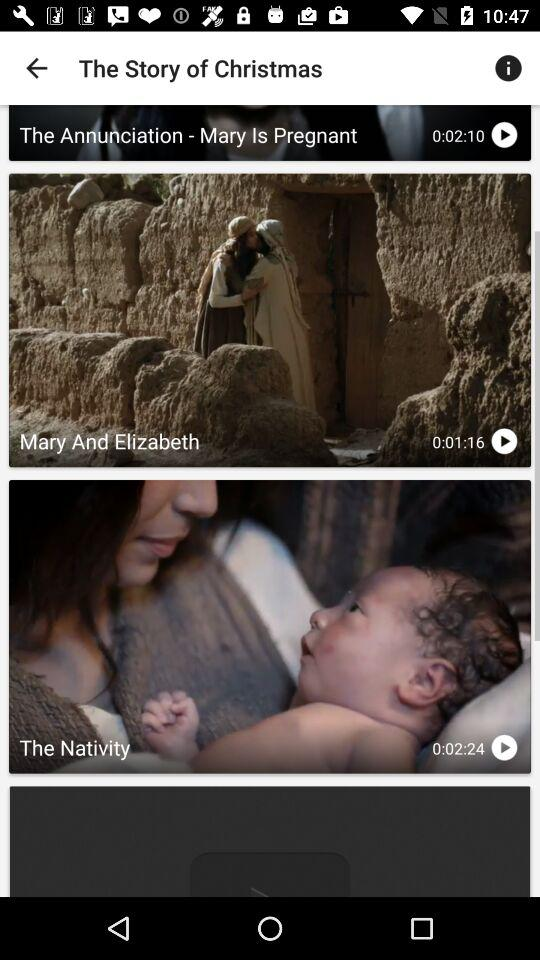What application can be used to sign up? The application "GOOGLE" can be used to sign up. 